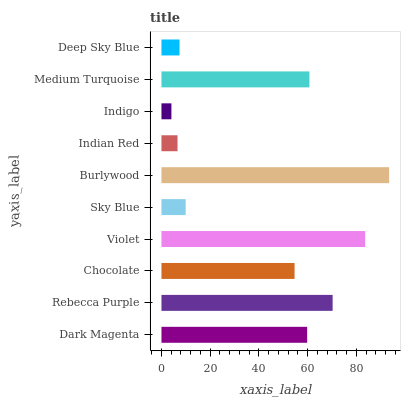Is Indigo the minimum?
Answer yes or no. Yes. Is Burlywood the maximum?
Answer yes or no. Yes. Is Rebecca Purple the minimum?
Answer yes or no. No. Is Rebecca Purple the maximum?
Answer yes or no. No. Is Rebecca Purple greater than Dark Magenta?
Answer yes or no. Yes. Is Dark Magenta less than Rebecca Purple?
Answer yes or no. Yes. Is Dark Magenta greater than Rebecca Purple?
Answer yes or no. No. Is Rebecca Purple less than Dark Magenta?
Answer yes or no. No. Is Dark Magenta the high median?
Answer yes or no. Yes. Is Chocolate the low median?
Answer yes or no. Yes. Is Indigo the high median?
Answer yes or no. No. Is Deep Sky Blue the low median?
Answer yes or no. No. 